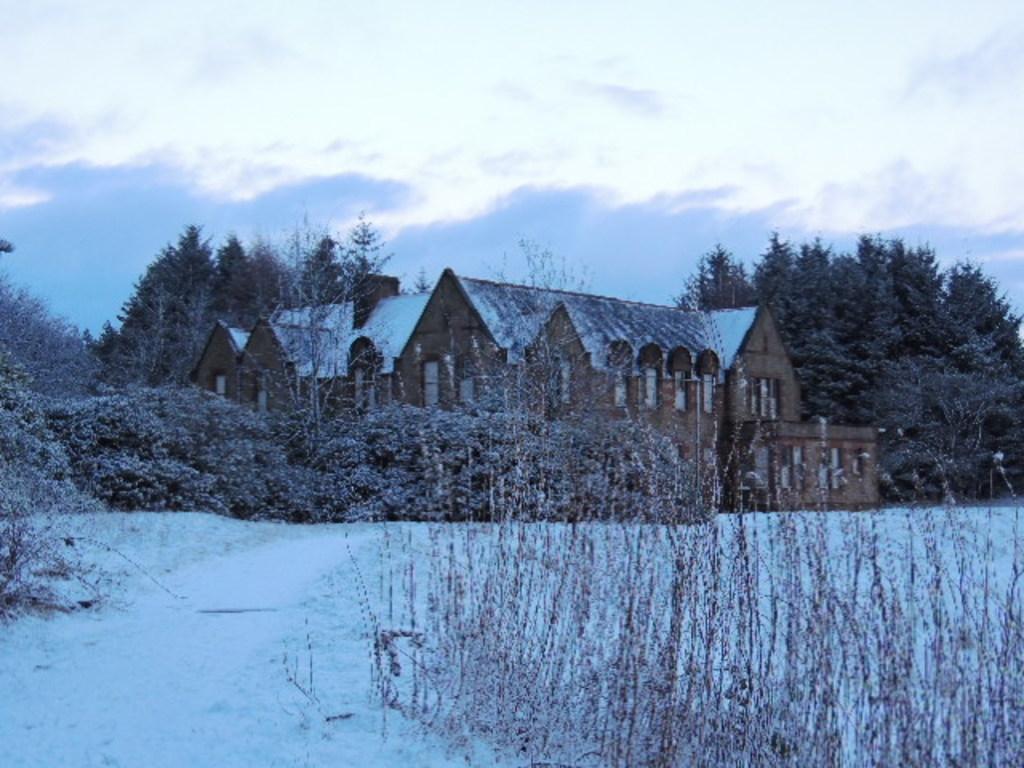Please provide a concise description of this image. In this image we can see a house, there are some trees, plants and snow, in the background we can see the sky with clouds. 